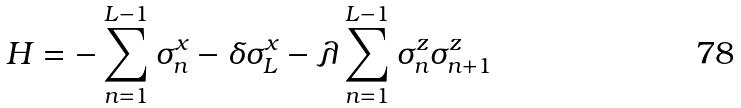<formula> <loc_0><loc_0><loc_500><loc_500>H = - \sum _ { n = 1 } ^ { L - 1 } \sigma _ { n } ^ { x } - \delta \sigma _ { L } ^ { x } - \lambda \sum _ { n = 1 } ^ { L - 1 } \sigma _ { n } ^ { z } \sigma _ { n + 1 } ^ { z }</formula> 